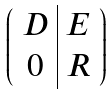Convert formula to latex. <formula><loc_0><loc_0><loc_500><loc_500>\left ( \begin{array} { c | c } D & E \\ 0 & R \end{array} \right )</formula> 